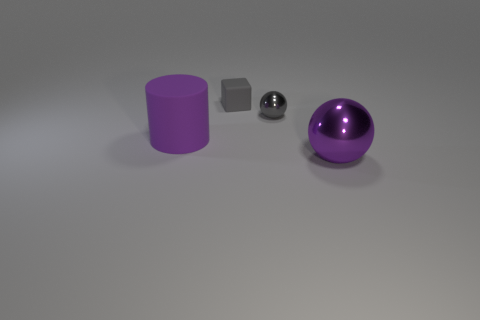Is there a yellow metal cube that has the same size as the rubber cube?
Ensure brevity in your answer.  No. Is the number of matte cylinders greater than the number of large red rubber objects?
Provide a short and direct response. Yes. There is a matte thing that is in front of the small gray metallic sphere; is it the same size as the ball that is in front of the large rubber cylinder?
Your response must be concise. Yes. What number of large purple things are on the right side of the cylinder and on the left side of the gray rubber cube?
Ensure brevity in your answer.  0. There is another large thing that is the same shape as the gray metal thing; what is its color?
Give a very brief answer. Purple. Are there fewer large green objects than small gray spheres?
Offer a very short reply. Yes. There is a gray metallic ball; is its size the same as the purple object that is behind the purple sphere?
Make the answer very short. No. What color is the ball that is behind the object to the right of the tiny ball?
Your answer should be compact. Gray. What number of things are either gray objects right of the gray rubber object or metallic objects that are behind the large purple cylinder?
Give a very brief answer. 1. Do the purple matte cylinder and the cube have the same size?
Your response must be concise. No. 